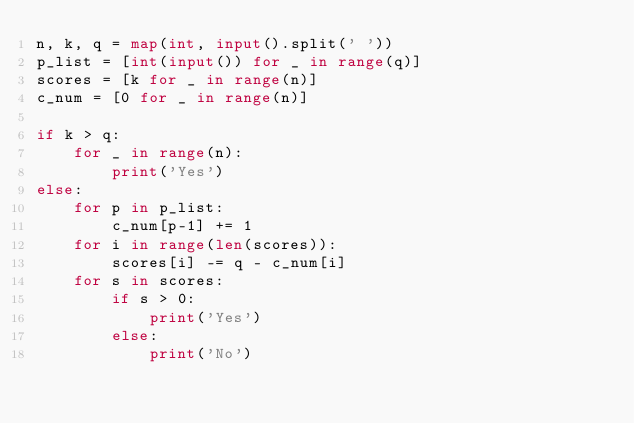Convert code to text. <code><loc_0><loc_0><loc_500><loc_500><_Python_>n, k, q = map(int, input().split(' '))
p_list = [int(input()) for _ in range(q)]
scores = [k for _ in range(n)]
c_num = [0 for _ in range(n)]

if k > q:
    for _ in range(n):
        print('Yes')
else:
    for p in p_list:
        c_num[p-1] += 1
    for i in range(len(scores)):
        scores[i] -= q - c_num[i]
    for s in scores:
        if s > 0:
            print('Yes')
        else:
            print('No')</code> 